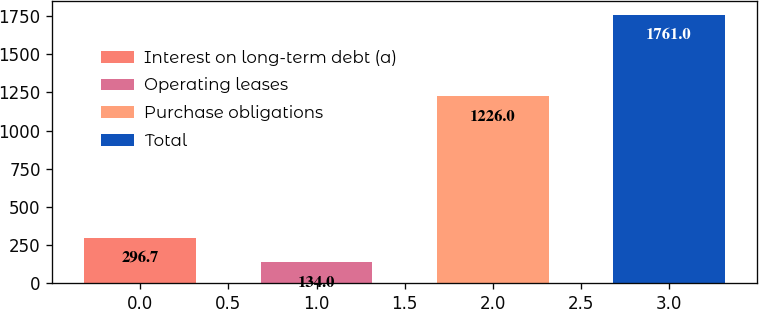Convert chart. <chart><loc_0><loc_0><loc_500><loc_500><bar_chart><fcel>Interest on long-term debt (a)<fcel>Operating leases<fcel>Purchase obligations<fcel>Total<nl><fcel>296.7<fcel>134<fcel>1226<fcel>1761<nl></chart> 